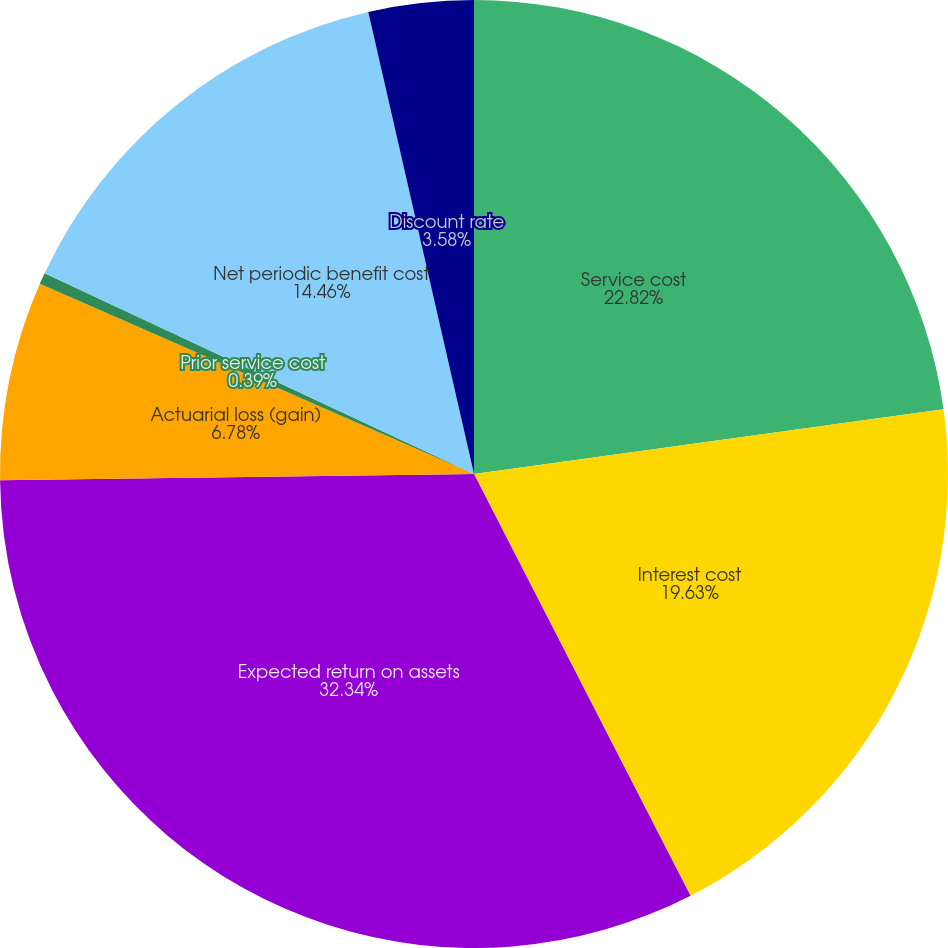Convert chart to OTSL. <chart><loc_0><loc_0><loc_500><loc_500><pie_chart><fcel>Service cost<fcel>Interest cost<fcel>Expected return on assets<fcel>Actuarial loss (gain)<fcel>Prior service cost<fcel>Net periodic benefit cost<fcel>Discount rate<nl><fcel>22.82%<fcel>19.63%<fcel>32.34%<fcel>6.78%<fcel>0.39%<fcel>14.46%<fcel>3.58%<nl></chart> 